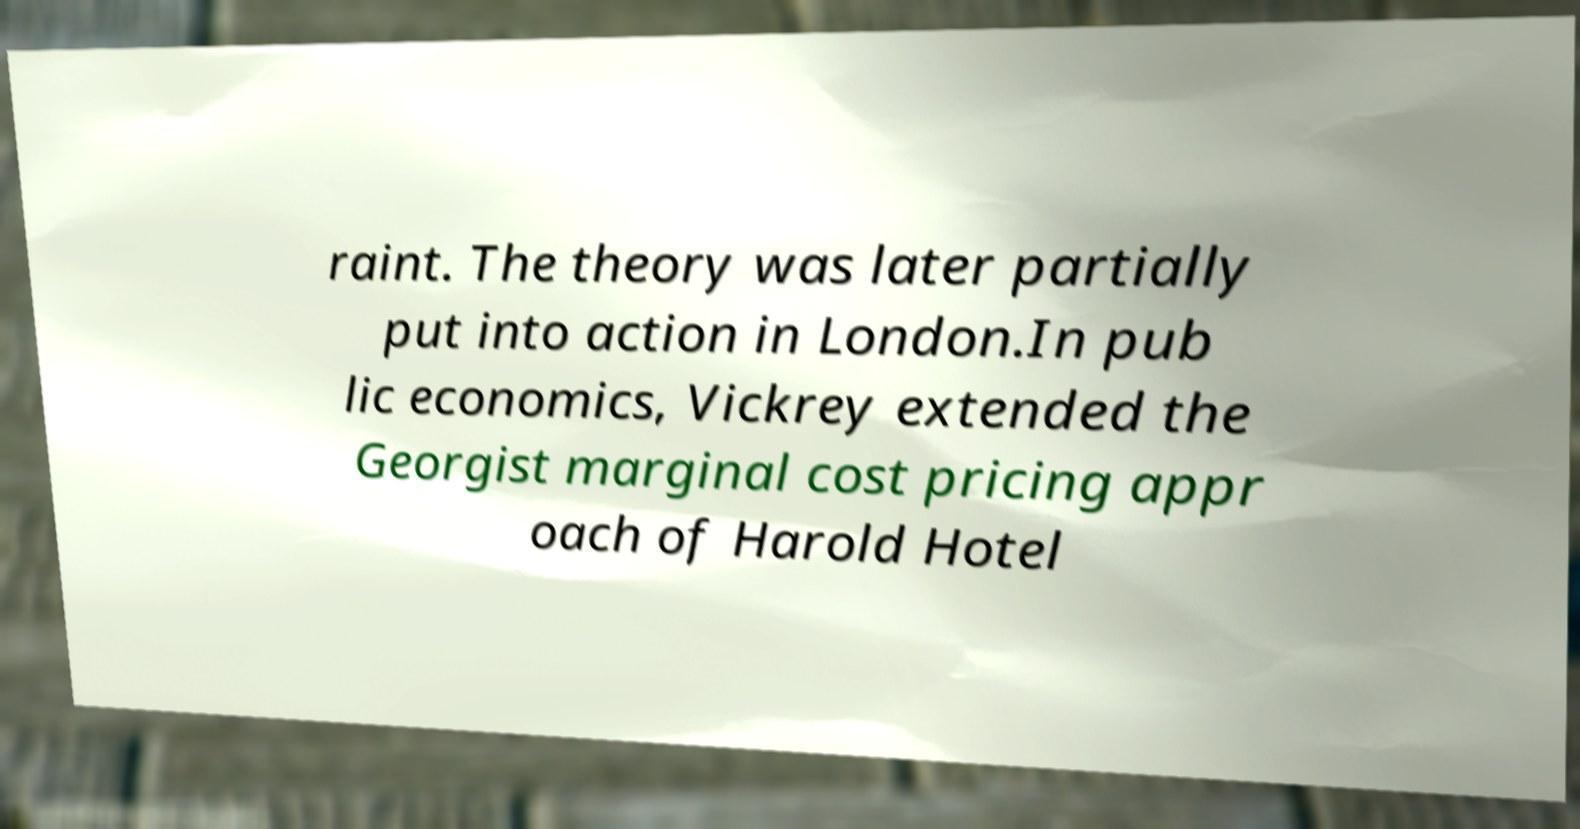Could you assist in decoding the text presented in this image and type it out clearly? raint. The theory was later partially put into action in London.In pub lic economics, Vickrey extended the Georgist marginal cost pricing appr oach of Harold Hotel 